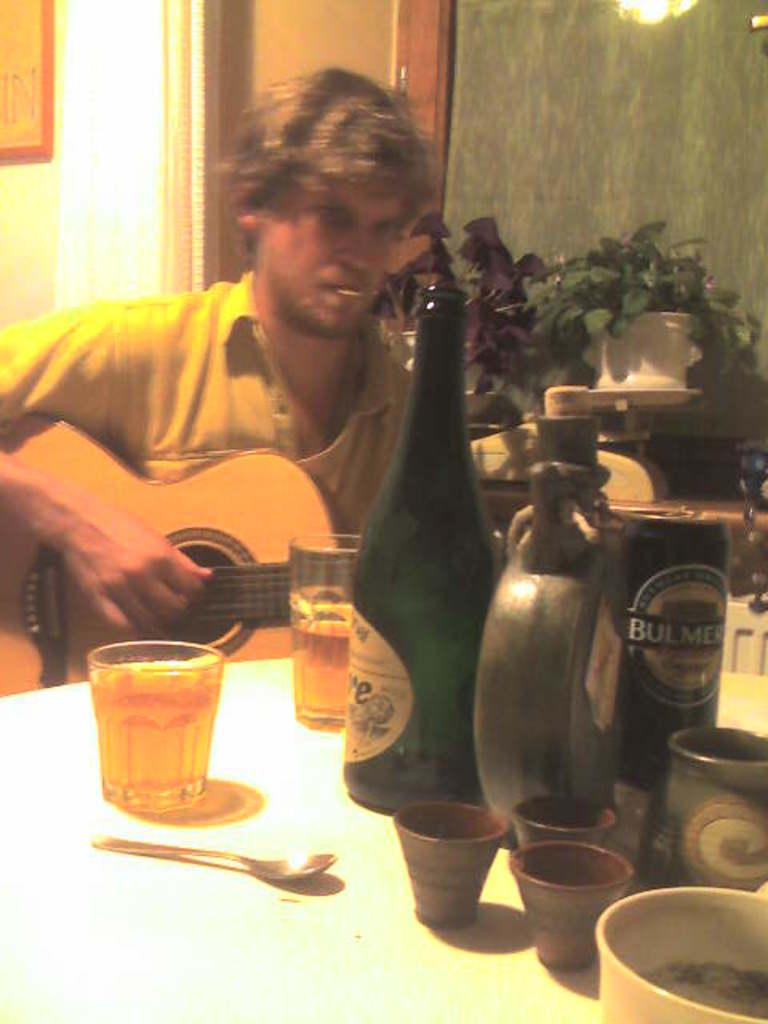<image>
Give a short and clear explanation of the subsequent image. A man playing a guitar with a can of Bulmers on a table. 